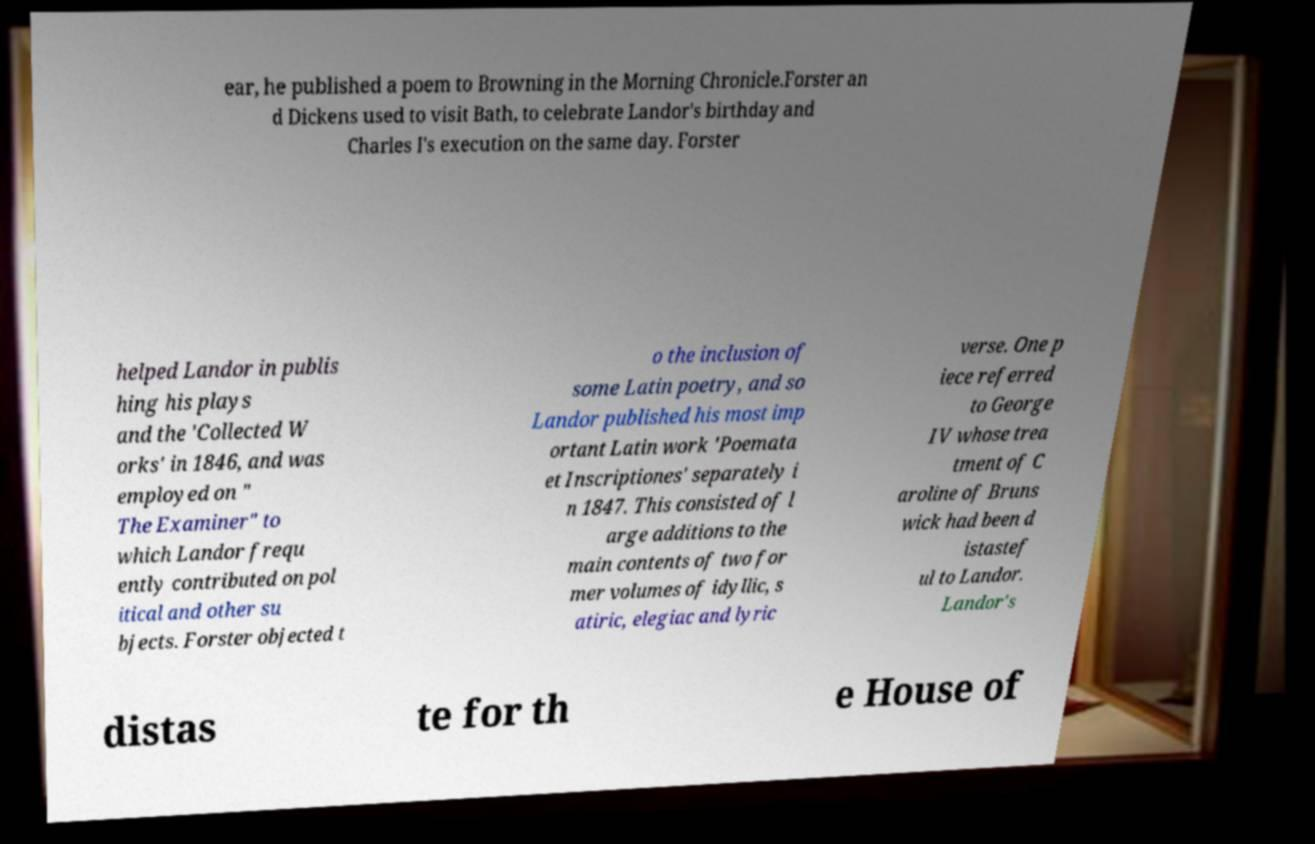Please read and relay the text visible in this image. What does it say? ear, he published a poem to Browning in the Morning Chronicle.Forster an d Dickens used to visit Bath, to celebrate Landor's birthday and Charles I's execution on the same day. Forster helped Landor in publis hing his plays and the 'Collected W orks' in 1846, and was employed on " The Examiner" to which Landor frequ ently contributed on pol itical and other su bjects. Forster objected t o the inclusion of some Latin poetry, and so Landor published his most imp ortant Latin work 'Poemata et Inscriptiones' separately i n 1847. This consisted of l arge additions to the main contents of two for mer volumes of idyllic, s atiric, elegiac and lyric verse. One p iece referred to George IV whose trea tment of C aroline of Bruns wick had been d istastef ul to Landor. Landor's distas te for th e House of 